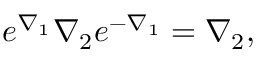Convert formula to latex. <formula><loc_0><loc_0><loc_500><loc_500>e ^ { \nabla _ { 1 } } \nabla _ { 2 } e ^ { - \nabla _ { 1 } } = \nabla _ { 2 } ,</formula> 